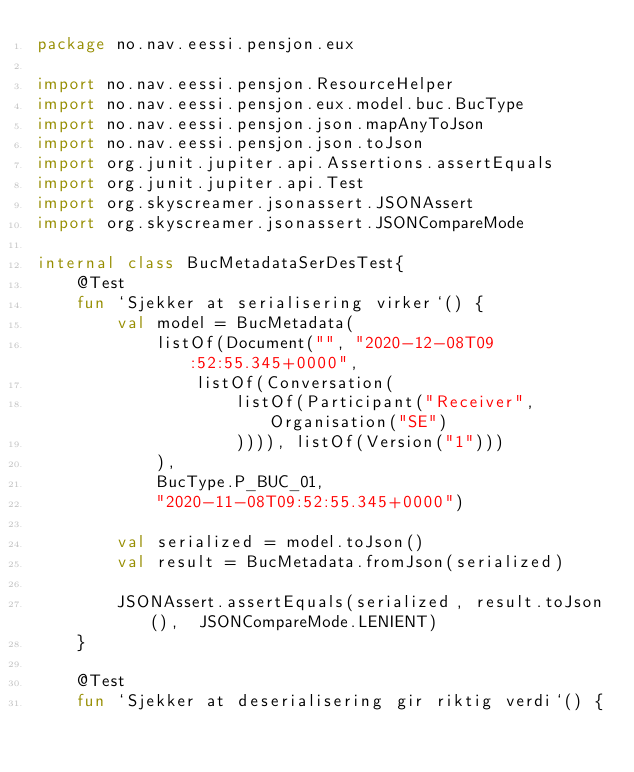Convert code to text. <code><loc_0><loc_0><loc_500><loc_500><_Kotlin_>package no.nav.eessi.pensjon.eux

import no.nav.eessi.pensjon.ResourceHelper
import no.nav.eessi.pensjon.eux.model.buc.BucType
import no.nav.eessi.pensjon.json.mapAnyToJson
import no.nav.eessi.pensjon.json.toJson
import org.junit.jupiter.api.Assertions.assertEquals
import org.junit.jupiter.api.Test
import org.skyscreamer.jsonassert.JSONAssert
import org.skyscreamer.jsonassert.JSONCompareMode

internal class BucMetadataSerDesTest{
    @Test
    fun `Sjekker at serialisering virker`() {
        val model = BucMetadata(
            listOf(Document("", "2020-12-08T09:52:55.345+0000",
                listOf(Conversation(
                    listOf(Participant("Receiver", Organisation("SE")
                    )))), listOf(Version("1")))
            ),
            BucType.P_BUC_01,
            "2020-11-08T09:52:55.345+0000")

        val serialized = model.toJson()
        val result = BucMetadata.fromJson(serialized)

        JSONAssert.assertEquals(serialized, result.toJson(),  JSONCompareMode.LENIENT)
    }

    @Test
    fun `Sjekker at deserialisering gir riktig verdi`() {</code> 